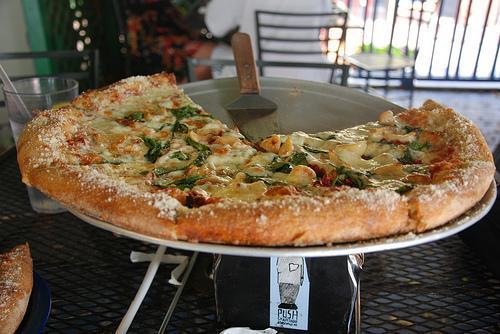How many pizza slices are left?
Give a very brief answer. 6. 